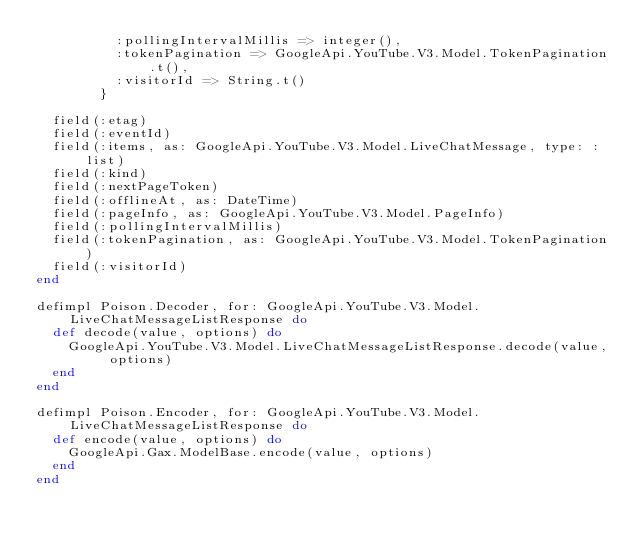<code> <loc_0><loc_0><loc_500><loc_500><_Elixir_>          :pollingIntervalMillis => integer(),
          :tokenPagination => GoogleApi.YouTube.V3.Model.TokenPagination.t(),
          :visitorId => String.t()
        }

  field(:etag)
  field(:eventId)
  field(:items, as: GoogleApi.YouTube.V3.Model.LiveChatMessage, type: :list)
  field(:kind)
  field(:nextPageToken)
  field(:offlineAt, as: DateTime)
  field(:pageInfo, as: GoogleApi.YouTube.V3.Model.PageInfo)
  field(:pollingIntervalMillis)
  field(:tokenPagination, as: GoogleApi.YouTube.V3.Model.TokenPagination)
  field(:visitorId)
end

defimpl Poison.Decoder, for: GoogleApi.YouTube.V3.Model.LiveChatMessageListResponse do
  def decode(value, options) do
    GoogleApi.YouTube.V3.Model.LiveChatMessageListResponse.decode(value, options)
  end
end

defimpl Poison.Encoder, for: GoogleApi.YouTube.V3.Model.LiveChatMessageListResponse do
  def encode(value, options) do
    GoogleApi.Gax.ModelBase.encode(value, options)
  end
end
</code> 